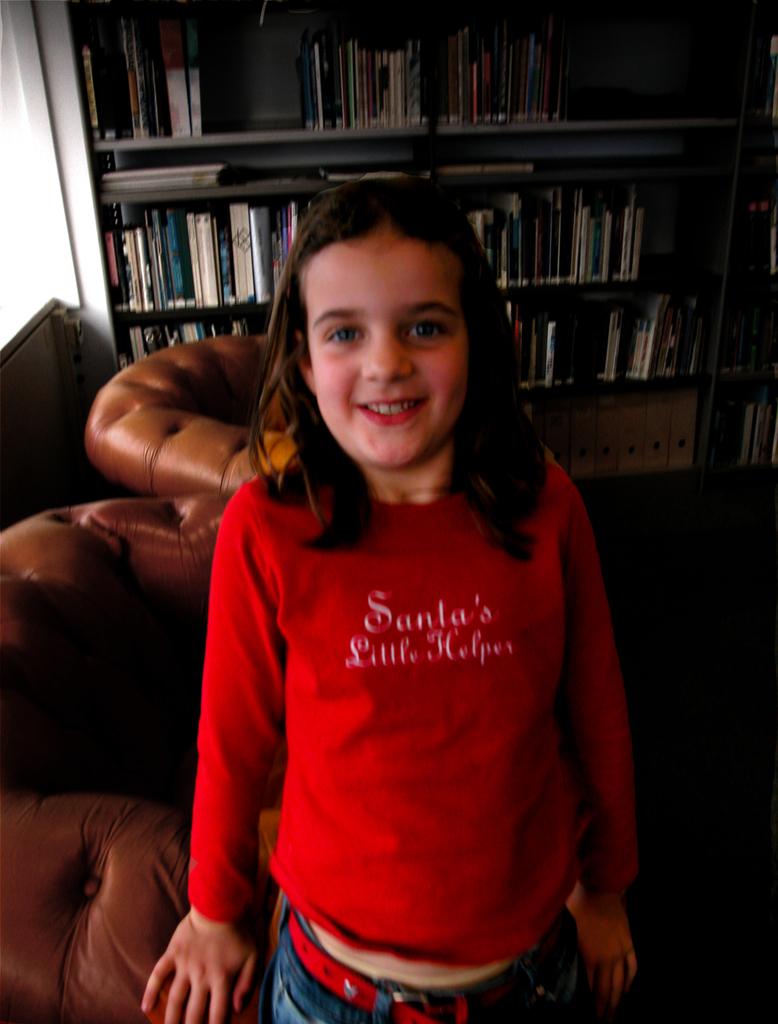What does the girl's shirt say?
Your answer should be compact. Santa's little helper. 